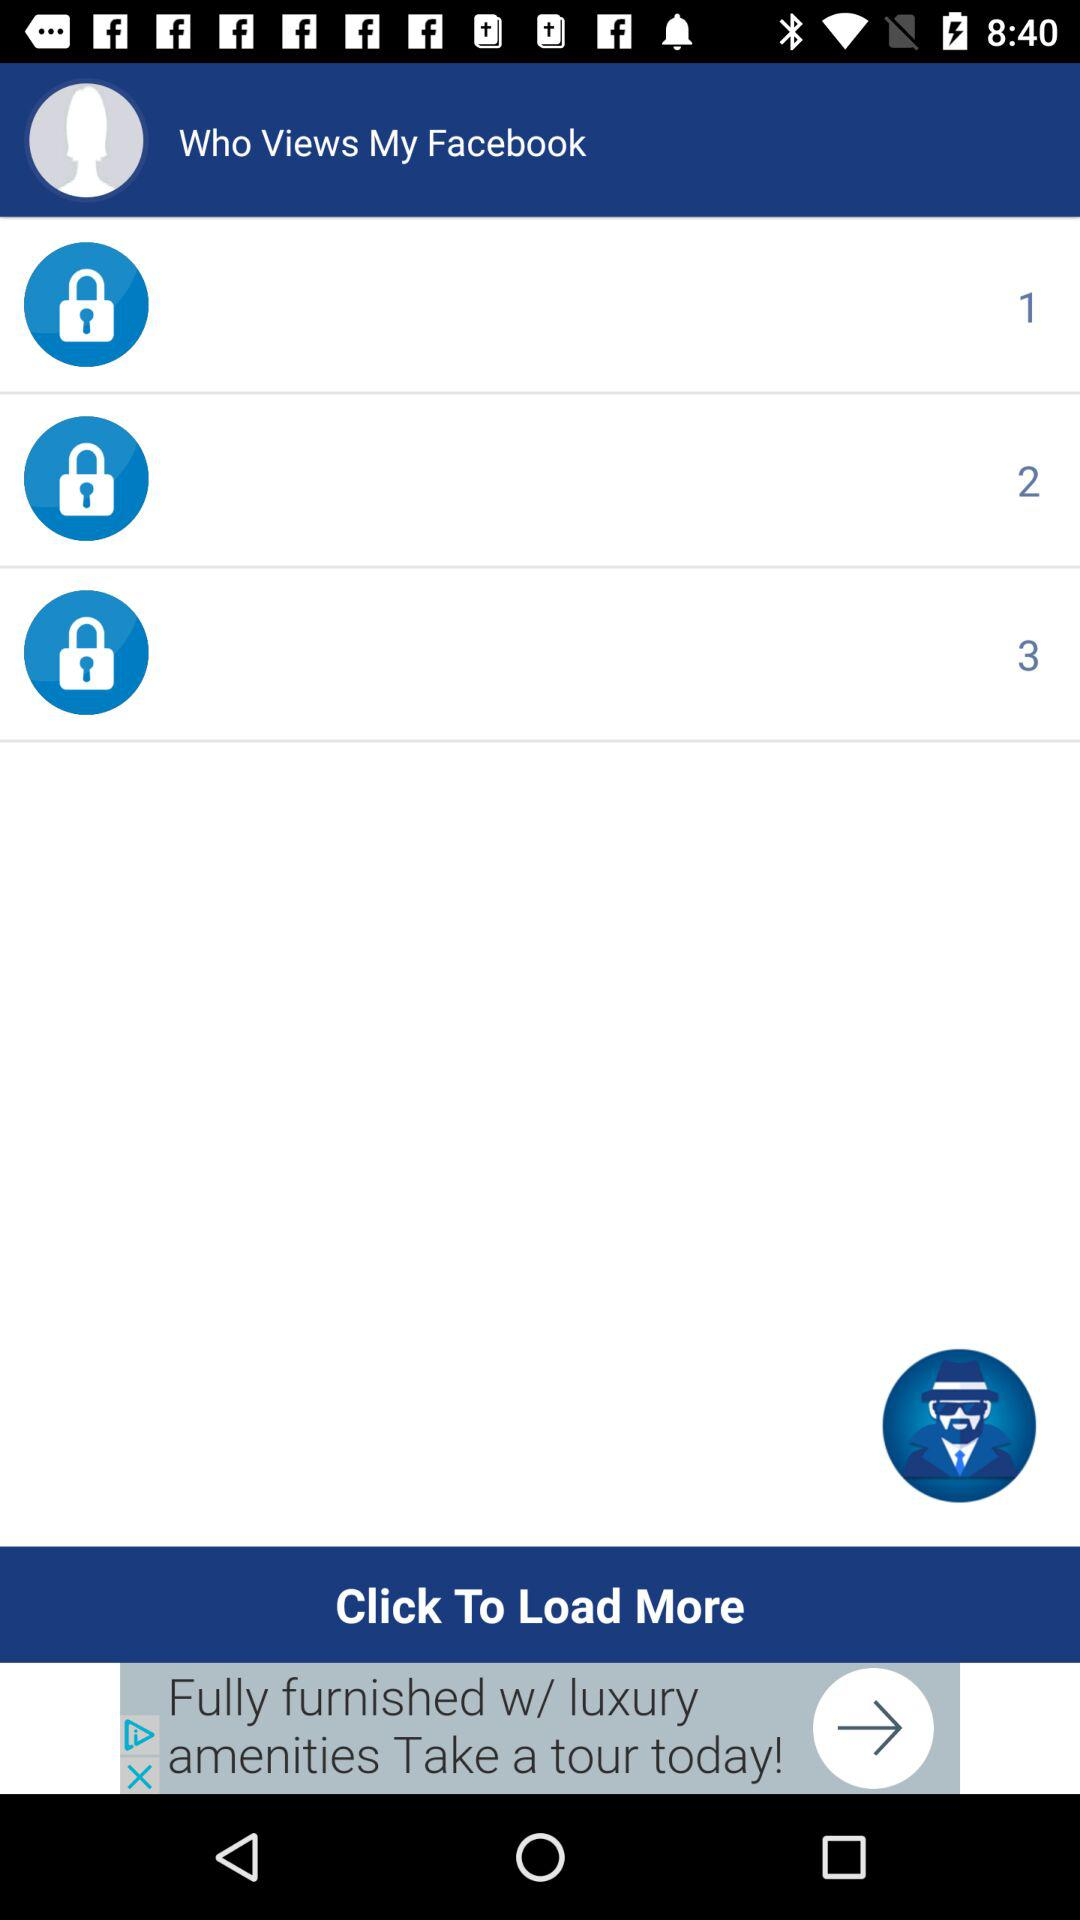How many people are wearing hats?
Answer the question using a single word or phrase. 1 